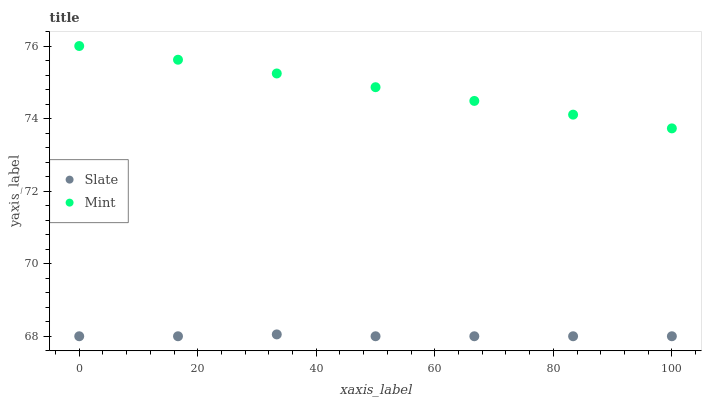Does Slate have the minimum area under the curve?
Answer yes or no. Yes. Does Mint have the maximum area under the curve?
Answer yes or no. Yes. Does Mint have the minimum area under the curve?
Answer yes or no. No. Is Mint the smoothest?
Answer yes or no. Yes. Is Slate the roughest?
Answer yes or no. Yes. Is Mint the roughest?
Answer yes or no. No. Does Slate have the lowest value?
Answer yes or no. Yes. Does Mint have the lowest value?
Answer yes or no. No. Does Mint have the highest value?
Answer yes or no. Yes. Is Slate less than Mint?
Answer yes or no. Yes. Is Mint greater than Slate?
Answer yes or no. Yes. Does Slate intersect Mint?
Answer yes or no. No. 